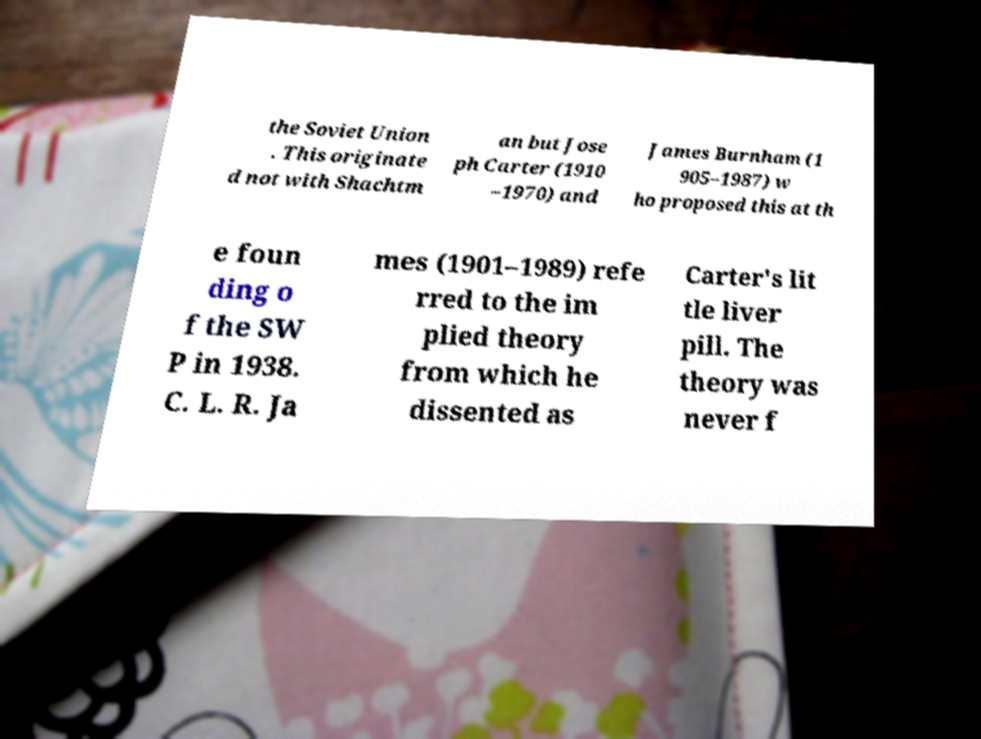Could you assist in decoding the text presented in this image and type it out clearly? the Soviet Union . This originate d not with Shachtm an but Jose ph Carter (1910 –1970) and James Burnham (1 905–1987) w ho proposed this at th e foun ding o f the SW P in 1938. C. L. R. Ja mes (1901–1989) refe rred to the im plied theory from which he dissented as Carter's lit tle liver pill. The theory was never f 